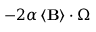<formula> <loc_0><loc_0><loc_500><loc_500>- 2 \alpha \left \langle B \right \rangle \cdot \Omega</formula> 